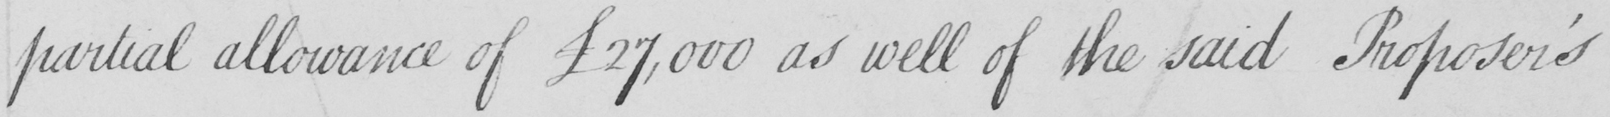What does this handwritten line say? partial allowance of £27,000 as well of the said Proposer ' s 